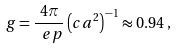<formula> <loc_0><loc_0><loc_500><loc_500>\ g = \frac { 4 \pi } { \ e p } \left ( c a ^ { 2 } \right ) ^ { - 1 } \approx 0 . 9 4 \, ,</formula> 